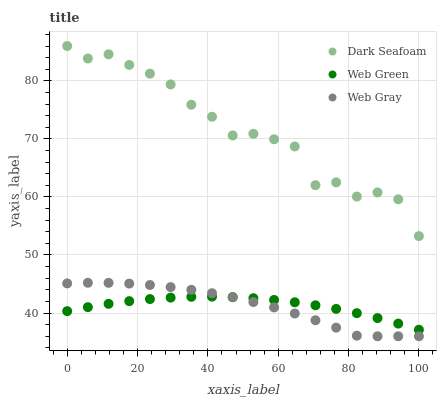Does Web Gray have the minimum area under the curve?
Answer yes or no. Yes. Does Dark Seafoam have the maximum area under the curve?
Answer yes or no. Yes. Does Web Green have the minimum area under the curve?
Answer yes or no. No. Does Web Green have the maximum area under the curve?
Answer yes or no. No. Is Web Green the smoothest?
Answer yes or no. Yes. Is Dark Seafoam the roughest?
Answer yes or no. Yes. Is Web Gray the smoothest?
Answer yes or no. No. Is Web Gray the roughest?
Answer yes or no. No. Does Web Gray have the lowest value?
Answer yes or no. Yes. Does Web Green have the lowest value?
Answer yes or no. No. Does Dark Seafoam have the highest value?
Answer yes or no. Yes. Does Web Gray have the highest value?
Answer yes or no. No. Is Web Green less than Dark Seafoam?
Answer yes or no. Yes. Is Dark Seafoam greater than Web Green?
Answer yes or no. Yes. Does Web Green intersect Web Gray?
Answer yes or no. Yes. Is Web Green less than Web Gray?
Answer yes or no. No. Is Web Green greater than Web Gray?
Answer yes or no. No. Does Web Green intersect Dark Seafoam?
Answer yes or no. No. 